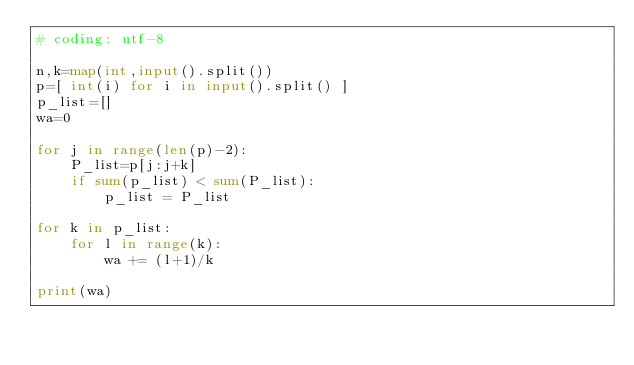<code> <loc_0><loc_0><loc_500><loc_500><_Python_># coding: utf-8

n,k=map(int,input().split())
p=[ int(i) for i in input().split() ]
p_list=[]
wa=0

for j in range(len(p)-2):
    P_list=p[j:j+k]
    if sum(p_list) < sum(P_list):
        p_list = P_list

for k in p_list:
    for l in range(k):
        wa += (l+1)/k

print(wa)</code> 